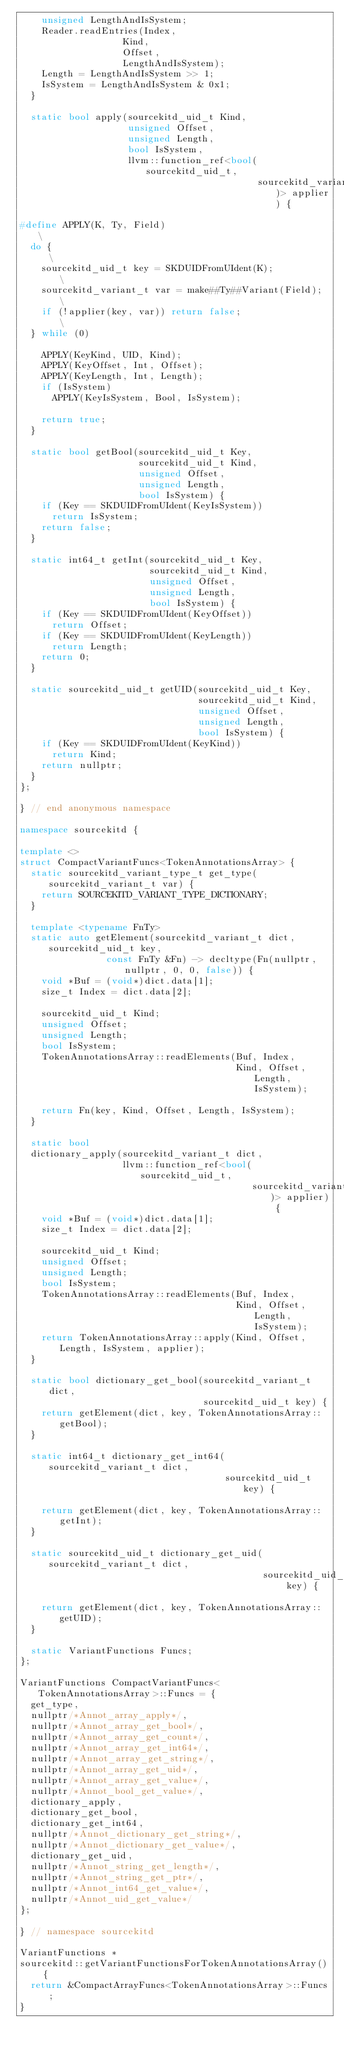Convert code to text. <code><loc_0><loc_0><loc_500><loc_500><_C++_>    unsigned LengthAndIsSystem;
    Reader.readEntries(Index,
                   Kind,
                   Offset,
                   LengthAndIsSystem);
    Length = LengthAndIsSystem >> 1;
    IsSystem = LengthAndIsSystem & 0x1;
  }

  static bool apply(sourcekitd_uid_t Kind,
                    unsigned Offset,
                    unsigned Length,
                    bool IsSystem,
                    llvm::function_ref<bool(sourcekitd_uid_t,
                                            sourcekitd_variant_t)> applier) {

#define APPLY(K, Ty, Field)                              \
  do {                                                   \
    sourcekitd_uid_t key = SKDUIDFromUIdent(K);          \
    sourcekitd_variant_t var = make##Ty##Variant(Field); \
    if (!applier(key, var)) return false;                \
  } while (0)

    APPLY(KeyKind, UID, Kind);
    APPLY(KeyOffset, Int, Offset);
    APPLY(KeyLength, Int, Length);
    if (IsSystem)
      APPLY(KeyIsSystem, Bool, IsSystem);

    return true;
  }

  static bool getBool(sourcekitd_uid_t Key,
                      sourcekitd_uid_t Kind,
                      unsigned Offset,
                      unsigned Length,
                      bool IsSystem) {
    if (Key == SKDUIDFromUIdent(KeyIsSystem))
      return IsSystem;
    return false;
  }

  static int64_t getInt(sourcekitd_uid_t Key,
                        sourcekitd_uid_t Kind,
                        unsigned Offset,
                        unsigned Length,
                        bool IsSystem) {
    if (Key == SKDUIDFromUIdent(KeyOffset))
      return Offset;
    if (Key == SKDUIDFromUIdent(KeyLength))
      return Length;
    return 0;
  }

  static sourcekitd_uid_t getUID(sourcekitd_uid_t Key,
                                 sourcekitd_uid_t Kind,
                                 unsigned Offset,
                                 unsigned Length,
                                 bool IsSystem) {
    if (Key == SKDUIDFromUIdent(KeyKind))
      return Kind;
    return nullptr;
  }
};

} // end anonymous namespace

namespace sourcekitd {

template <>
struct CompactVariantFuncs<TokenAnnotationsArray> {
  static sourcekitd_variant_type_t get_type(sourcekitd_variant_t var) {
    return SOURCEKITD_VARIANT_TYPE_DICTIONARY;
  }

  template <typename FnTy>
  static auto getElement(sourcekitd_variant_t dict, sourcekitd_uid_t key,
                const FnTy &Fn) -> decltype(Fn(nullptr, nullptr, 0, 0, false)) {
    void *Buf = (void*)dict.data[1];
    size_t Index = dict.data[2];

    sourcekitd_uid_t Kind;
    unsigned Offset;
    unsigned Length;
    bool IsSystem;
    TokenAnnotationsArray::readElements(Buf, Index,
                                        Kind, Offset, Length, IsSystem);

    return Fn(key, Kind, Offset, Length, IsSystem);
  }
  
  static bool
  dictionary_apply(sourcekitd_variant_t dict,
                   llvm::function_ref<bool(sourcekitd_uid_t,
                                           sourcekitd_variant_t)> applier) {
    void *Buf = (void*)dict.data[1];
    size_t Index = dict.data[2];

    sourcekitd_uid_t Kind;
    unsigned Offset;
    unsigned Length;
    bool IsSystem;
    TokenAnnotationsArray::readElements(Buf, Index,
                                        Kind, Offset, Length, IsSystem);
    return TokenAnnotationsArray::apply(Kind, Offset, Length, IsSystem, applier);
  }

  static bool dictionary_get_bool(sourcekitd_variant_t dict,
                                  sourcekitd_uid_t key) {
    return getElement(dict, key, TokenAnnotationsArray::getBool);
  }

  static int64_t dictionary_get_int64(sourcekitd_variant_t dict,
                                      sourcekitd_uid_t key) {

    return getElement(dict, key, TokenAnnotationsArray::getInt);
  }

  static sourcekitd_uid_t dictionary_get_uid(sourcekitd_variant_t dict,
                                             sourcekitd_uid_t key) {

    return getElement(dict, key, TokenAnnotationsArray::getUID);
  }

  static VariantFunctions Funcs;
};

VariantFunctions CompactVariantFuncs<TokenAnnotationsArray>::Funcs = {
  get_type,
  nullptr/*Annot_array_apply*/,
  nullptr/*Annot_array_get_bool*/,
  nullptr/*Annot_array_get_count*/,
  nullptr/*Annot_array_get_int64*/,
  nullptr/*Annot_array_get_string*/,
  nullptr/*Annot_array_get_uid*/,
  nullptr/*Annot_array_get_value*/,
  nullptr/*Annot_bool_get_value*/,
  dictionary_apply,
  dictionary_get_bool,
  dictionary_get_int64,
  nullptr/*Annot_dictionary_get_string*/,
  nullptr/*Annot_dictionary_get_value*/,
  dictionary_get_uid,
  nullptr/*Annot_string_get_length*/,
  nullptr/*Annot_string_get_ptr*/,
  nullptr/*Annot_int64_get_value*/,
  nullptr/*Annot_uid_get_value*/
};

} // namespace sourcekitd

VariantFunctions *
sourcekitd::getVariantFunctionsForTokenAnnotationsArray() {
  return &CompactArrayFuncs<TokenAnnotationsArray>::Funcs;
}
</code> 